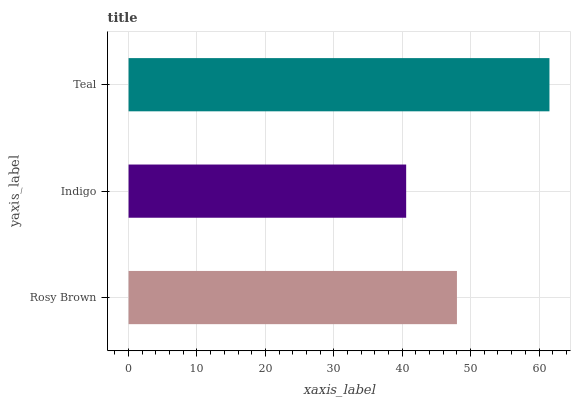Is Indigo the minimum?
Answer yes or no. Yes. Is Teal the maximum?
Answer yes or no. Yes. Is Teal the minimum?
Answer yes or no. No. Is Indigo the maximum?
Answer yes or no. No. Is Teal greater than Indigo?
Answer yes or no. Yes. Is Indigo less than Teal?
Answer yes or no. Yes. Is Indigo greater than Teal?
Answer yes or no. No. Is Teal less than Indigo?
Answer yes or no. No. Is Rosy Brown the high median?
Answer yes or no. Yes. Is Rosy Brown the low median?
Answer yes or no. Yes. Is Indigo the high median?
Answer yes or no. No. Is Teal the low median?
Answer yes or no. No. 